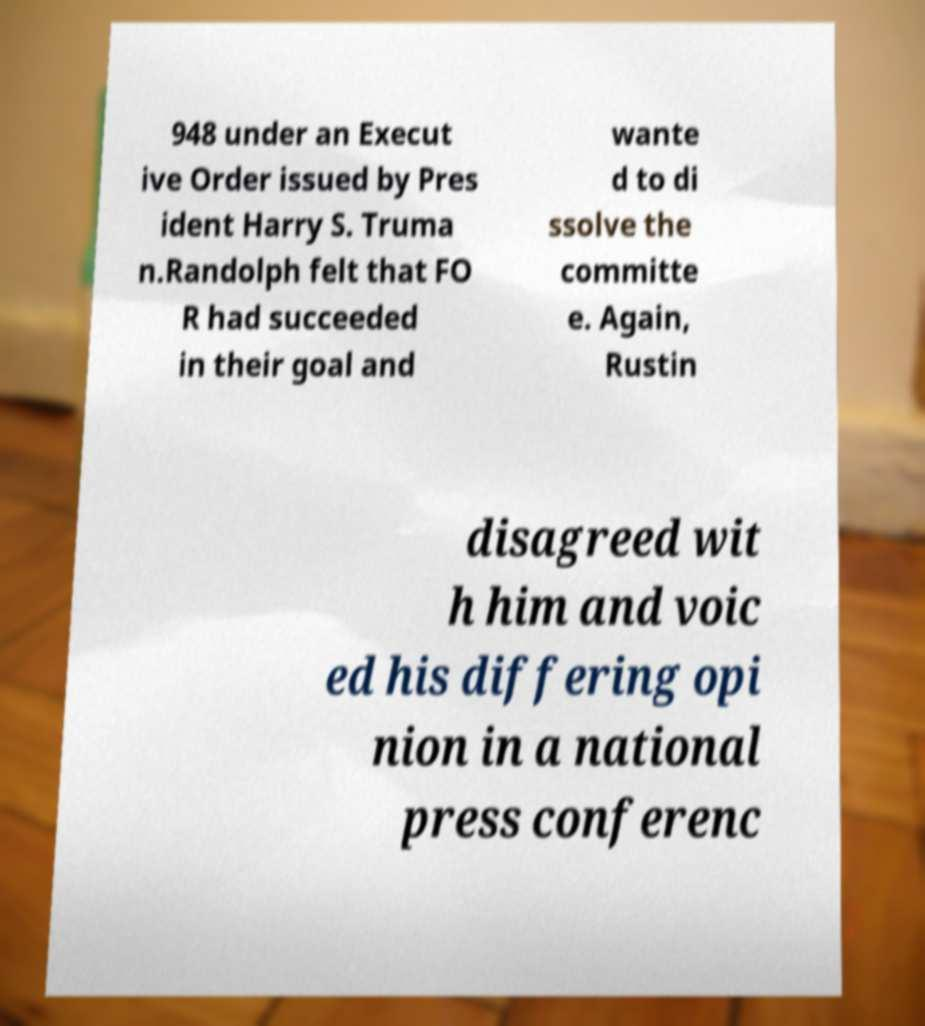There's text embedded in this image that I need extracted. Can you transcribe it verbatim? 948 under an Execut ive Order issued by Pres ident Harry S. Truma n.Randolph felt that FO R had succeeded in their goal and wante d to di ssolve the committe e. Again, Rustin disagreed wit h him and voic ed his differing opi nion in a national press conferenc 